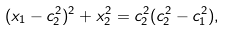Convert formula to latex. <formula><loc_0><loc_0><loc_500><loc_500>( x _ { 1 } - c _ { 2 } ^ { 2 } ) ^ { 2 } + x _ { 2 } ^ { 2 } = c _ { 2 } ^ { 2 } ( c _ { 2 } ^ { 2 } - c _ { 1 } ^ { 2 } ) ,</formula> 